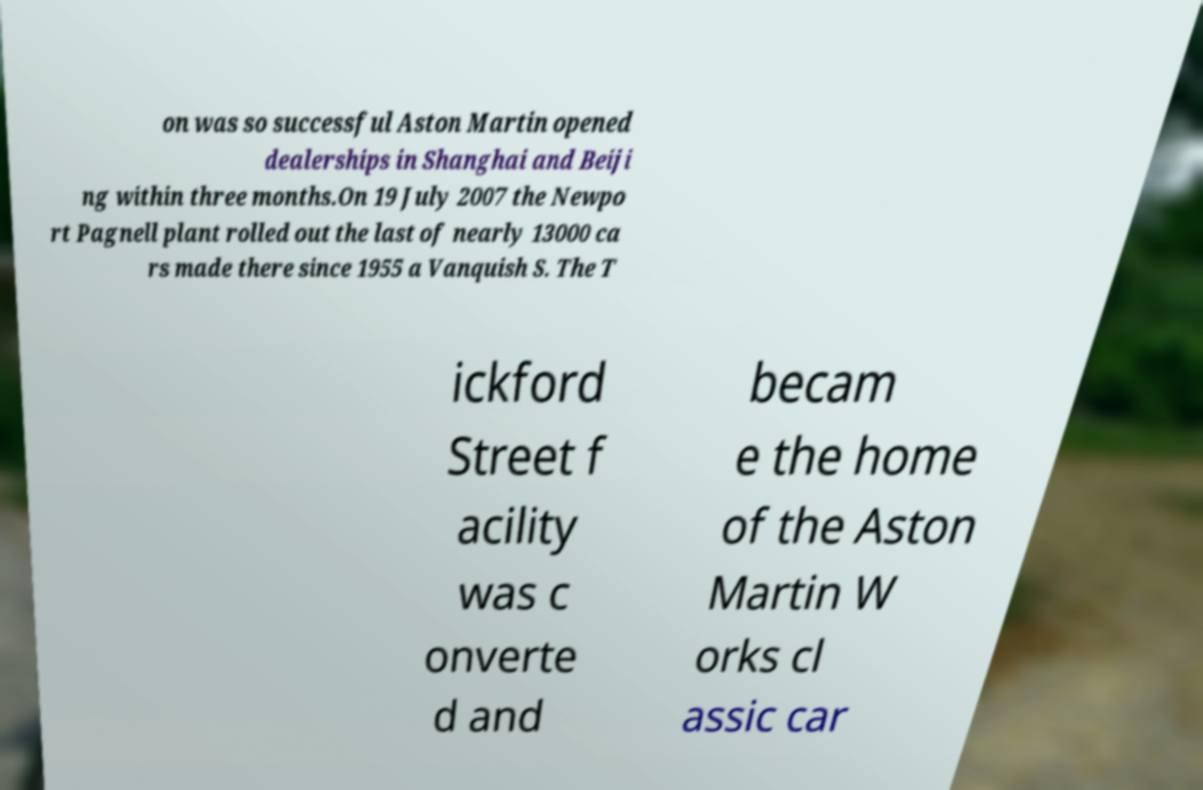Could you extract and type out the text from this image? on was so successful Aston Martin opened dealerships in Shanghai and Beiji ng within three months.On 19 July 2007 the Newpo rt Pagnell plant rolled out the last of nearly 13000 ca rs made there since 1955 a Vanquish S. The T ickford Street f acility was c onverte d and becam e the home of the Aston Martin W orks cl assic car 